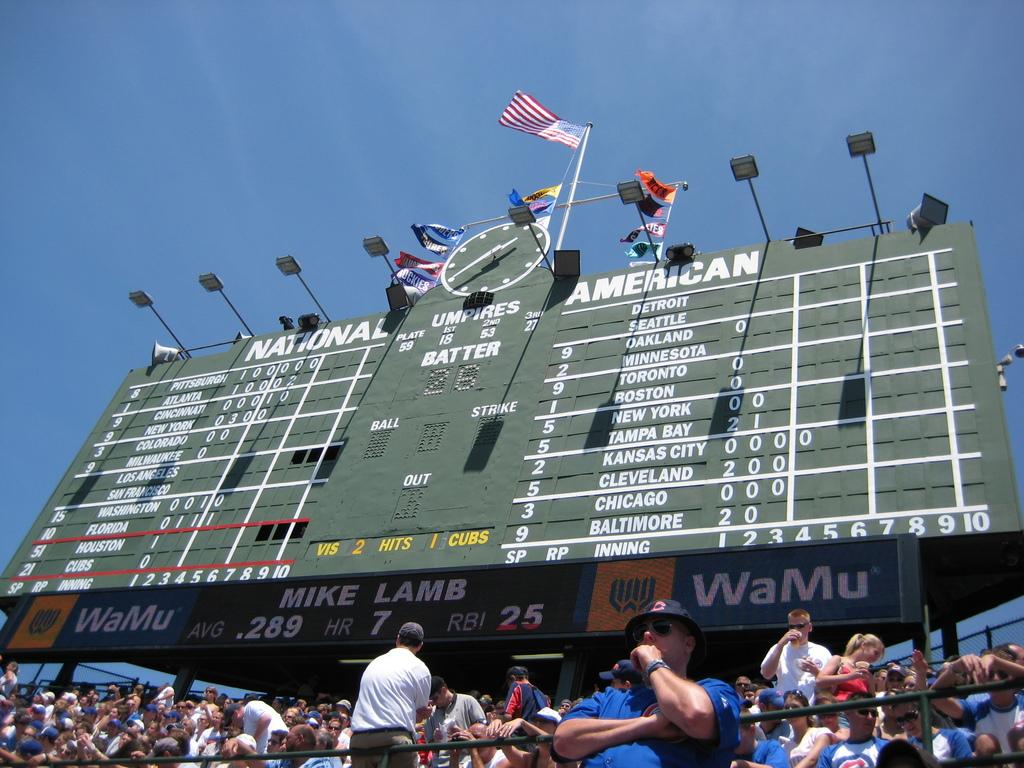<image>
Write a terse but informative summary of the picture. A giant scoreboard with National and American written on has an American Flag at the top 